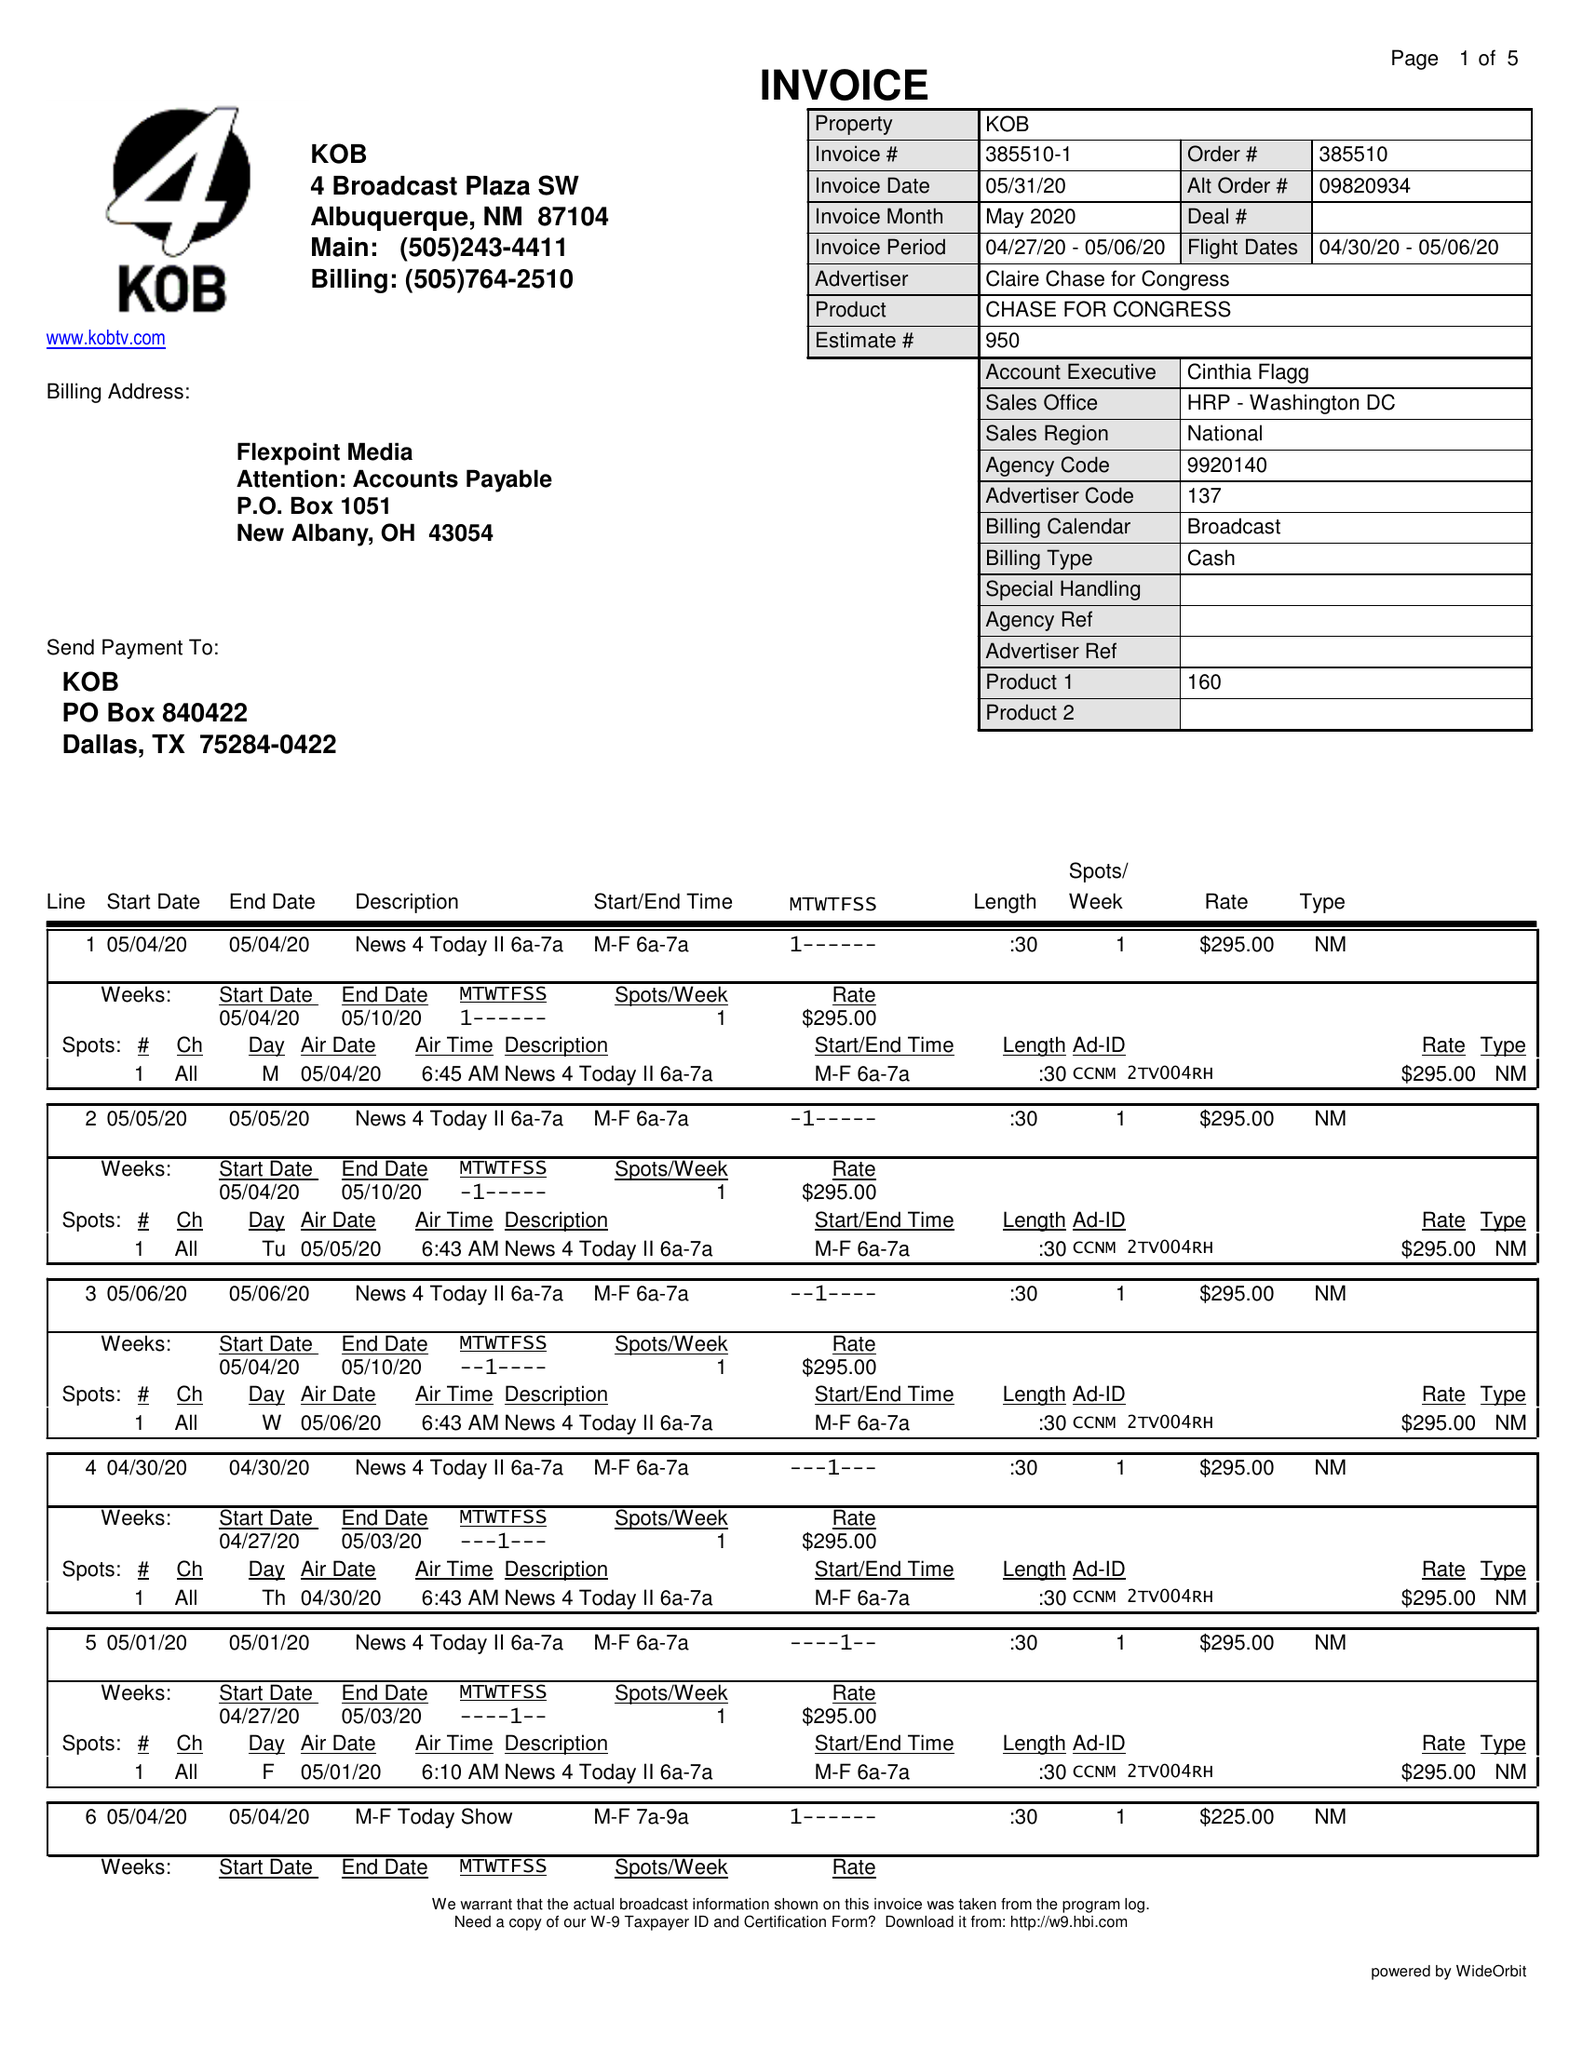What is the value for the flight_from?
Answer the question using a single word or phrase. 04/30/20 